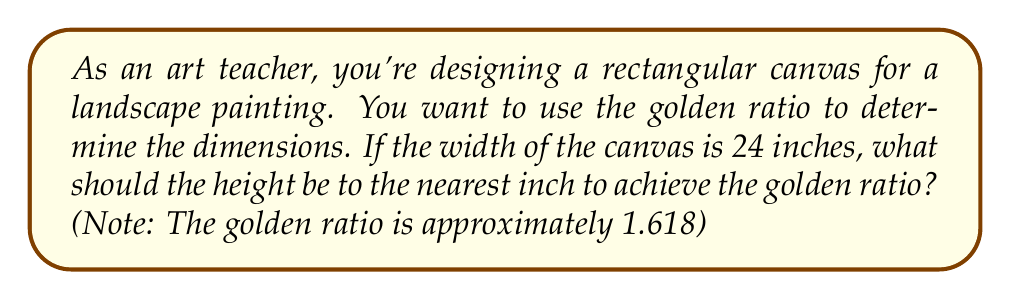Solve this math problem. Let's approach this step-by-step:

1) The golden ratio is defined as:

   $$\frac{\text{longer side}}{\text{shorter side}} \approx 1.618$$

2) In this case, we want the ratio of height to width to be 1.618:

   $$\frac{\text{height}}{\text{width}} \approx 1.618$$

3) We know the width is 24 inches, so we can set up the equation:

   $$\frac{\text{height}}{24} \approx 1.618$$

4) To solve for height, multiply both sides by 24:

   $$\text{height} \approx 1.618 \times 24$$

5) Calculate:

   $$\text{height} \approx 38.832$$

6) Rounding to the nearest inch:

   $$\text{height} \approx 39\text{ inches}$$

Therefore, to achieve the golden ratio, the height of the canvas should be approximately 39 inches.
Answer: 39 inches 